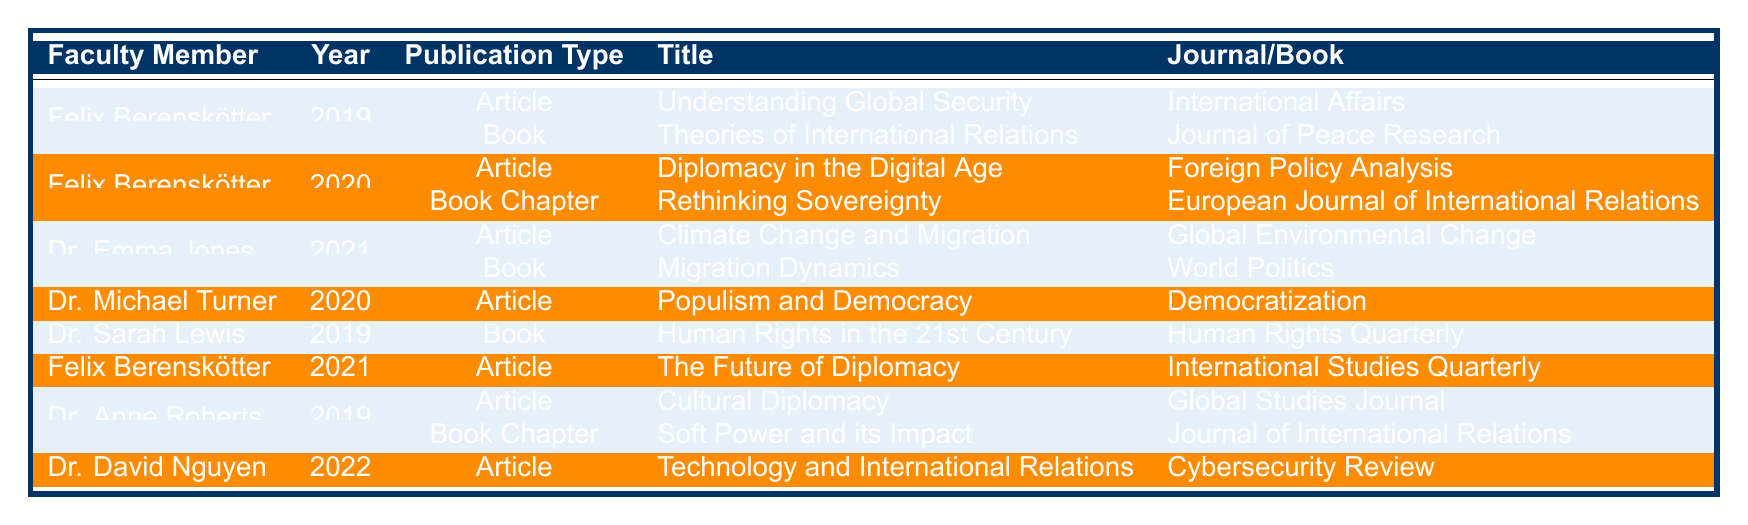What publications did Felix Berenskötter contribute to in 2019? In the table, Felix Berenskötter has two publications in 2019: "Understanding Global Security" in the journal "International Affairs" (Article) and "Theories of International Relations" in the journal "Journal of Peace Research" (Book).
Answer: Two publications How many publications did Dr. Emma Jones author in 2021? The table indicates that Dr. Emma Jones has two publications listed for 2021: "Climate Change and Migration" (Article) in "Global Environmental Change" and "Migration Dynamics" (Book) in "World Politics."
Answer: Two publications Was there a publication by Dr. Michael Turner in 2021? According to the table, there is no entry for Dr. Michael Turner in 2021; he only has a publication listed in 2020.
Answer: No Who published the article "Diplomacy in the Digital Age"? The table shows that "Diplomacy in the Digital Age" is an article authored by Felix Berenskötter in 2020, published in "Foreign Policy Analysis."
Answer: Felix Berenskötter Which faculty member had a publication in the year 2022? The table reveals that Dr. David Nguyen is the only faculty member with a publication in 2022, which is "Technology and International Relations" (Article) in "Cybersecurity Review."
Answer: Dr. David Nguyen How many book publications did Felix Berenskötter have across all years? Reviewing Felix Berenskötter's publications, he had one book publication in 2019 ("Theories of International Relations") and one in 2020 ("Rethinking Sovereignty" as a Book Chapter), totaling two book publications.
Answer: Two book publications How many unique faculty members authored publications in 2019? From the table, the faculty members who published in 2019 are Felix Berenskötter, Dr. Sarah Lewis, and Dr. Anne Roberts, totaling three unique faculty members.
Answer: Three unique faculty members What is the total number of publications listed for Felix Berenskötter? Analyzing the table, Felix Berenskötter has two publications in 2019, two in 2020, and one in 2021, leading to a total of five publications across all listed years.
Answer: Five publications Which year had the most publications, and how many were there? The years 2019 and 2020 both had a total of five publications each. However, the publications are distributed among different authors, making 2019 and 2020 tied for the highest number of publications at five.
Answer: 2019 and 2020 had five publications each Did any faculty member publish more than one article in a single year? In 2021, Dr. Emma Jones has two publications, but they are a combination of an article and a book. Since the question specifies articles only, no faculty member published more than one article in a single year.
Answer: No 